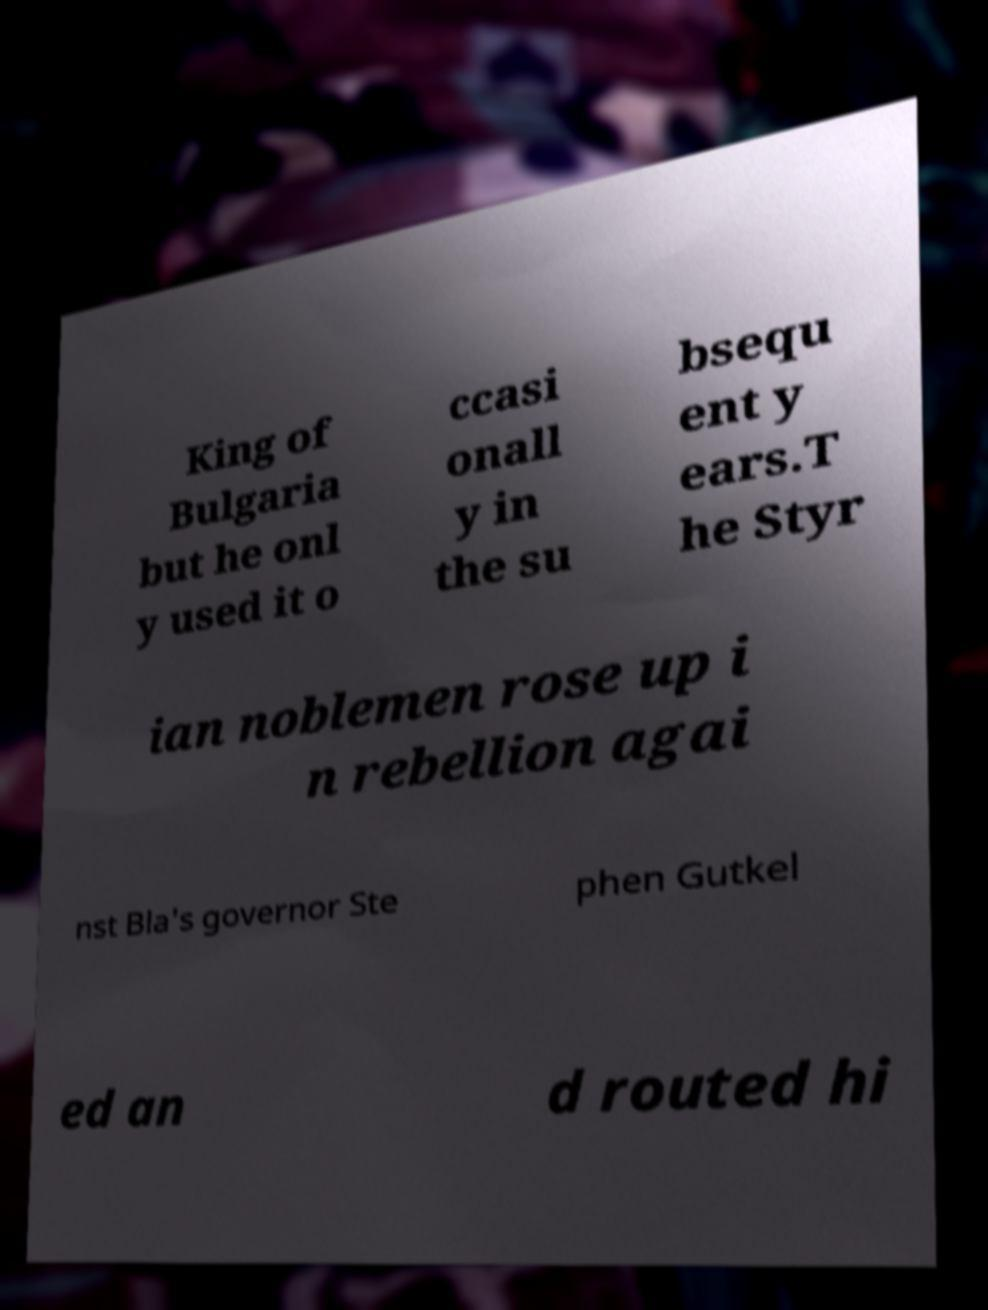Could you assist in decoding the text presented in this image and type it out clearly? King of Bulgaria but he onl y used it o ccasi onall y in the su bsequ ent y ears.T he Styr ian noblemen rose up i n rebellion agai nst Bla's governor Ste phen Gutkel ed an d routed hi 